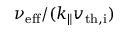Convert formula to latex. <formula><loc_0><loc_0><loc_500><loc_500>\nu _ { e f f } / ( k _ { \| } v _ { t h , i } )</formula> 